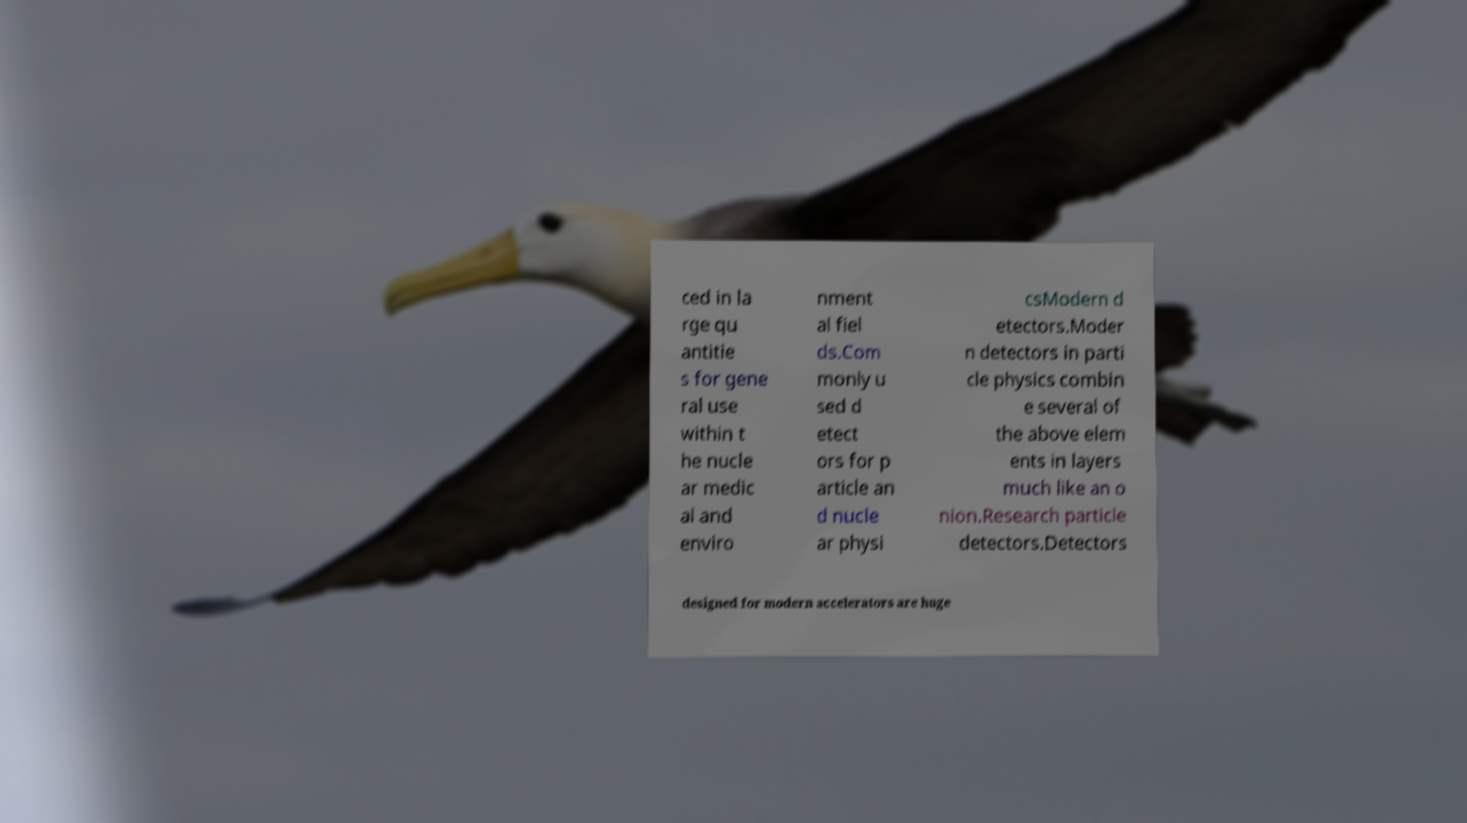Please identify and transcribe the text found in this image. ced in la rge qu antitie s for gene ral use within t he nucle ar medic al and enviro nment al fiel ds.Com monly u sed d etect ors for p article an d nucle ar physi csModern d etectors.Moder n detectors in parti cle physics combin e several of the above elem ents in layers much like an o nion.Research particle detectors.Detectors designed for modern accelerators are huge 